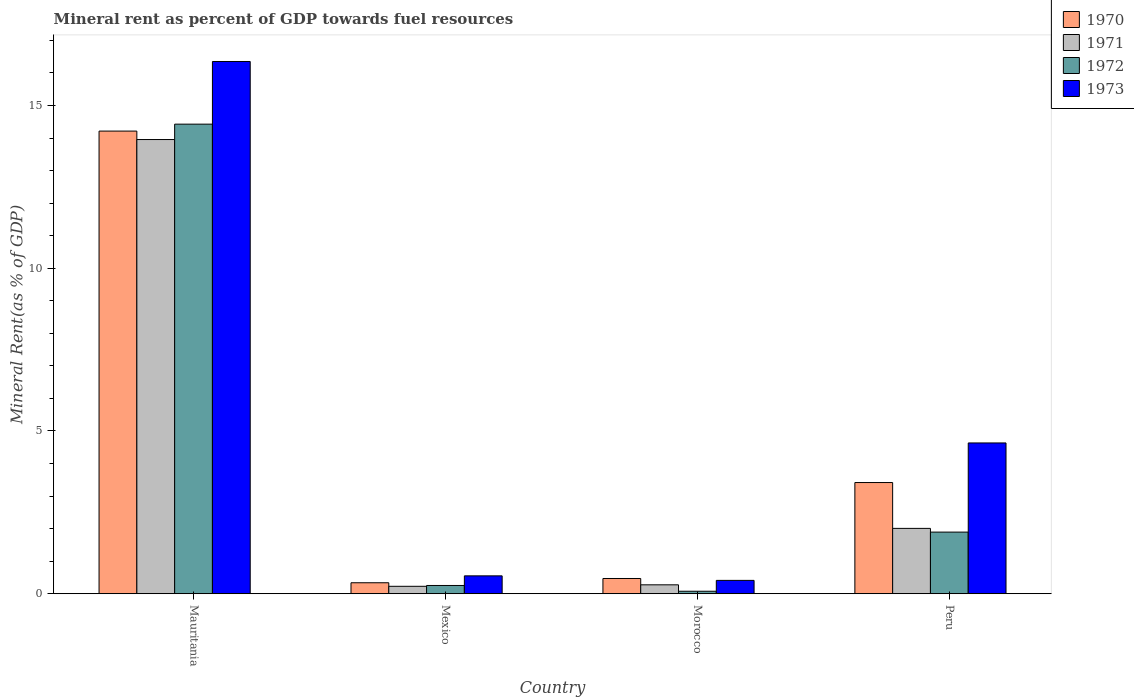How many groups of bars are there?
Ensure brevity in your answer.  4. Are the number of bars per tick equal to the number of legend labels?
Provide a succinct answer. Yes. How many bars are there on the 1st tick from the right?
Provide a succinct answer. 4. What is the label of the 3rd group of bars from the left?
Provide a short and direct response. Morocco. In how many cases, is the number of bars for a given country not equal to the number of legend labels?
Your answer should be compact. 0. What is the mineral rent in 1971 in Mexico?
Ensure brevity in your answer.  0.23. Across all countries, what is the maximum mineral rent in 1971?
Make the answer very short. 13.95. Across all countries, what is the minimum mineral rent in 1970?
Make the answer very short. 0.34. In which country was the mineral rent in 1970 maximum?
Make the answer very short. Mauritania. In which country was the mineral rent in 1972 minimum?
Provide a succinct answer. Morocco. What is the total mineral rent in 1970 in the graph?
Make the answer very short. 18.44. What is the difference between the mineral rent in 1971 in Morocco and that in Peru?
Provide a succinct answer. -1.73. What is the difference between the mineral rent in 1970 in Morocco and the mineral rent in 1971 in Mexico?
Provide a succinct answer. 0.24. What is the average mineral rent in 1972 per country?
Keep it short and to the point. 4.16. What is the difference between the mineral rent of/in 1971 and mineral rent of/in 1973 in Mexico?
Offer a very short reply. -0.32. What is the ratio of the mineral rent in 1970 in Morocco to that in Peru?
Your answer should be very brief. 0.14. Is the mineral rent in 1971 in Mauritania less than that in Mexico?
Provide a short and direct response. No. What is the difference between the highest and the second highest mineral rent in 1972?
Keep it short and to the point. -1.64. What is the difference between the highest and the lowest mineral rent in 1972?
Keep it short and to the point. 14.35. What does the 3rd bar from the left in Mauritania represents?
Ensure brevity in your answer.  1972. How many bars are there?
Provide a succinct answer. 16. Are the values on the major ticks of Y-axis written in scientific E-notation?
Your answer should be compact. No. Where does the legend appear in the graph?
Your answer should be very brief. Top right. How are the legend labels stacked?
Make the answer very short. Vertical. What is the title of the graph?
Offer a very short reply. Mineral rent as percent of GDP towards fuel resources. What is the label or title of the X-axis?
Give a very brief answer. Country. What is the label or title of the Y-axis?
Your answer should be compact. Mineral Rent(as % of GDP). What is the Mineral Rent(as % of GDP) of 1970 in Mauritania?
Ensure brevity in your answer.  14.21. What is the Mineral Rent(as % of GDP) in 1971 in Mauritania?
Provide a short and direct response. 13.95. What is the Mineral Rent(as % of GDP) of 1972 in Mauritania?
Give a very brief answer. 14.43. What is the Mineral Rent(as % of GDP) in 1973 in Mauritania?
Your answer should be very brief. 16.35. What is the Mineral Rent(as % of GDP) in 1970 in Mexico?
Provide a succinct answer. 0.34. What is the Mineral Rent(as % of GDP) of 1971 in Mexico?
Give a very brief answer. 0.23. What is the Mineral Rent(as % of GDP) in 1972 in Mexico?
Your response must be concise. 0.25. What is the Mineral Rent(as % of GDP) in 1973 in Mexico?
Your response must be concise. 0.55. What is the Mineral Rent(as % of GDP) of 1970 in Morocco?
Keep it short and to the point. 0.47. What is the Mineral Rent(as % of GDP) in 1971 in Morocco?
Provide a short and direct response. 0.27. What is the Mineral Rent(as % of GDP) in 1972 in Morocco?
Keep it short and to the point. 0.08. What is the Mineral Rent(as % of GDP) of 1973 in Morocco?
Keep it short and to the point. 0.41. What is the Mineral Rent(as % of GDP) of 1970 in Peru?
Your answer should be very brief. 3.42. What is the Mineral Rent(as % of GDP) in 1971 in Peru?
Make the answer very short. 2.01. What is the Mineral Rent(as % of GDP) of 1972 in Peru?
Ensure brevity in your answer.  1.89. What is the Mineral Rent(as % of GDP) in 1973 in Peru?
Make the answer very short. 4.63. Across all countries, what is the maximum Mineral Rent(as % of GDP) in 1970?
Provide a short and direct response. 14.21. Across all countries, what is the maximum Mineral Rent(as % of GDP) of 1971?
Offer a very short reply. 13.95. Across all countries, what is the maximum Mineral Rent(as % of GDP) of 1972?
Make the answer very short. 14.43. Across all countries, what is the maximum Mineral Rent(as % of GDP) of 1973?
Keep it short and to the point. 16.35. Across all countries, what is the minimum Mineral Rent(as % of GDP) of 1970?
Offer a terse response. 0.34. Across all countries, what is the minimum Mineral Rent(as % of GDP) in 1971?
Give a very brief answer. 0.23. Across all countries, what is the minimum Mineral Rent(as % of GDP) of 1972?
Make the answer very short. 0.08. Across all countries, what is the minimum Mineral Rent(as % of GDP) in 1973?
Ensure brevity in your answer.  0.41. What is the total Mineral Rent(as % of GDP) of 1970 in the graph?
Offer a very short reply. 18.44. What is the total Mineral Rent(as % of GDP) in 1971 in the graph?
Make the answer very short. 16.46. What is the total Mineral Rent(as % of GDP) in 1972 in the graph?
Your answer should be very brief. 16.65. What is the total Mineral Rent(as % of GDP) in 1973 in the graph?
Provide a succinct answer. 21.94. What is the difference between the Mineral Rent(as % of GDP) in 1970 in Mauritania and that in Mexico?
Give a very brief answer. 13.88. What is the difference between the Mineral Rent(as % of GDP) of 1971 in Mauritania and that in Mexico?
Make the answer very short. 13.72. What is the difference between the Mineral Rent(as % of GDP) in 1972 in Mauritania and that in Mexico?
Make the answer very short. 14.17. What is the difference between the Mineral Rent(as % of GDP) of 1973 in Mauritania and that in Mexico?
Provide a succinct answer. 15.8. What is the difference between the Mineral Rent(as % of GDP) in 1970 in Mauritania and that in Morocco?
Provide a short and direct response. 13.74. What is the difference between the Mineral Rent(as % of GDP) of 1971 in Mauritania and that in Morocco?
Ensure brevity in your answer.  13.68. What is the difference between the Mineral Rent(as % of GDP) of 1972 in Mauritania and that in Morocco?
Provide a short and direct response. 14.35. What is the difference between the Mineral Rent(as % of GDP) in 1973 in Mauritania and that in Morocco?
Give a very brief answer. 15.94. What is the difference between the Mineral Rent(as % of GDP) of 1970 in Mauritania and that in Peru?
Your answer should be very brief. 10.8. What is the difference between the Mineral Rent(as % of GDP) in 1971 in Mauritania and that in Peru?
Offer a terse response. 11.94. What is the difference between the Mineral Rent(as % of GDP) in 1972 in Mauritania and that in Peru?
Keep it short and to the point. 12.53. What is the difference between the Mineral Rent(as % of GDP) of 1973 in Mauritania and that in Peru?
Offer a very short reply. 11.72. What is the difference between the Mineral Rent(as % of GDP) of 1970 in Mexico and that in Morocco?
Ensure brevity in your answer.  -0.13. What is the difference between the Mineral Rent(as % of GDP) in 1971 in Mexico and that in Morocco?
Keep it short and to the point. -0.05. What is the difference between the Mineral Rent(as % of GDP) of 1972 in Mexico and that in Morocco?
Keep it short and to the point. 0.18. What is the difference between the Mineral Rent(as % of GDP) of 1973 in Mexico and that in Morocco?
Ensure brevity in your answer.  0.14. What is the difference between the Mineral Rent(as % of GDP) in 1970 in Mexico and that in Peru?
Offer a terse response. -3.08. What is the difference between the Mineral Rent(as % of GDP) in 1971 in Mexico and that in Peru?
Offer a terse response. -1.78. What is the difference between the Mineral Rent(as % of GDP) of 1972 in Mexico and that in Peru?
Offer a terse response. -1.64. What is the difference between the Mineral Rent(as % of GDP) of 1973 in Mexico and that in Peru?
Offer a terse response. -4.08. What is the difference between the Mineral Rent(as % of GDP) in 1970 in Morocco and that in Peru?
Keep it short and to the point. -2.95. What is the difference between the Mineral Rent(as % of GDP) of 1971 in Morocco and that in Peru?
Provide a succinct answer. -1.73. What is the difference between the Mineral Rent(as % of GDP) of 1972 in Morocco and that in Peru?
Provide a short and direct response. -1.82. What is the difference between the Mineral Rent(as % of GDP) of 1973 in Morocco and that in Peru?
Provide a succinct answer. -4.22. What is the difference between the Mineral Rent(as % of GDP) in 1970 in Mauritania and the Mineral Rent(as % of GDP) in 1971 in Mexico?
Your response must be concise. 13.98. What is the difference between the Mineral Rent(as % of GDP) of 1970 in Mauritania and the Mineral Rent(as % of GDP) of 1972 in Mexico?
Your response must be concise. 13.96. What is the difference between the Mineral Rent(as % of GDP) in 1970 in Mauritania and the Mineral Rent(as % of GDP) in 1973 in Mexico?
Your answer should be very brief. 13.66. What is the difference between the Mineral Rent(as % of GDP) of 1971 in Mauritania and the Mineral Rent(as % of GDP) of 1972 in Mexico?
Your answer should be compact. 13.7. What is the difference between the Mineral Rent(as % of GDP) in 1971 in Mauritania and the Mineral Rent(as % of GDP) in 1973 in Mexico?
Give a very brief answer. 13.4. What is the difference between the Mineral Rent(as % of GDP) of 1972 in Mauritania and the Mineral Rent(as % of GDP) of 1973 in Mexico?
Provide a short and direct response. 13.88. What is the difference between the Mineral Rent(as % of GDP) in 1970 in Mauritania and the Mineral Rent(as % of GDP) in 1971 in Morocco?
Make the answer very short. 13.94. What is the difference between the Mineral Rent(as % of GDP) of 1970 in Mauritania and the Mineral Rent(as % of GDP) of 1972 in Morocco?
Give a very brief answer. 14.14. What is the difference between the Mineral Rent(as % of GDP) of 1970 in Mauritania and the Mineral Rent(as % of GDP) of 1973 in Morocco?
Provide a succinct answer. 13.8. What is the difference between the Mineral Rent(as % of GDP) in 1971 in Mauritania and the Mineral Rent(as % of GDP) in 1972 in Morocco?
Provide a short and direct response. 13.88. What is the difference between the Mineral Rent(as % of GDP) in 1971 in Mauritania and the Mineral Rent(as % of GDP) in 1973 in Morocco?
Give a very brief answer. 13.54. What is the difference between the Mineral Rent(as % of GDP) of 1972 in Mauritania and the Mineral Rent(as % of GDP) of 1973 in Morocco?
Ensure brevity in your answer.  14.02. What is the difference between the Mineral Rent(as % of GDP) in 1970 in Mauritania and the Mineral Rent(as % of GDP) in 1971 in Peru?
Your answer should be very brief. 12.2. What is the difference between the Mineral Rent(as % of GDP) of 1970 in Mauritania and the Mineral Rent(as % of GDP) of 1972 in Peru?
Provide a succinct answer. 12.32. What is the difference between the Mineral Rent(as % of GDP) of 1970 in Mauritania and the Mineral Rent(as % of GDP) of 1973 in Peru?
Offer a terse response. 9.58. What is the difference between the Mineral Rent(as % of GDP) of 1971 in Mauritania and the Mineral Rent(as % of GDP) of 1972 in Peru?
Offer a terse response. 12.06. What is the difference between the Mineral Rent(as % of GDP) in 1971 in Mauritania and the Mineral Rent(as % of GDP) in 1973 in Peru?
Ensure brevity in your answer.  9.32. What is the difference between the Mineral Rent(as % of GDP) in 1972 in Mauritania and the Mineral Rent(as % of GDP) in 1973 in Peru?
Ensure brevity in your answer.  9.79. What is the difference between the Mineral Rent(as % of GDP) in 1970 in Mexico and the Mineral Rent(as % of GDP) in 1971 in Morocco?
Your answer should be compact. 0.06. What is the difference between the Mineral Rent(as % of GDP) of 1970 in Mexico and the Mineral Rent(as % of GDP) of 1972 in Morocco?
Offer a terse response. 0.26. What is the difference between the Mineral Rent(as % of GDP) of 1970 in Mexico and the Mineral Rent(as % of GDP) of 1973 in Morocco?
Your response must be concise. -0.07. What is the difference between the Mineral Rent(as % of GDP) in 1971 in Mexico and the Mineral Rent(as % of GDP) in 1972 in Morocco?
Give a very brief answer. 0.15. What is the difference between the Mineral Rent(as % of GDP) of 1971 in Mexico and the Mineral Rent(as % of GDP) of 1973 in Morocco?
Offer a terse response. -0.18. What is the difference between the Mineral Rent(as % of GDP) in 1972 in Mexico and the Mineral Rent(as % of GDP) in 1973 in Morocco?
Provide a succinct answer. -0.16. What is the difference between the Mineral Rent(as % of GDP) of 1970 in Mexico and the Mineral Rent(as % of GDP) of 1971 in Peru?
Your response must be concise. -1.67. What is the difference between the Mineral Rent(as % of GDP) in 1970 in Mexico and the Mineral Rent(as % of GDP) in 1972 in Peru?
Make the answer very short. -1.56. What is the difference between the Mineral Rent(as % of GDP) in 1970 in Mexico and the Mineral Rent(as % of GDP) in 1973 in Peru?
Make the answer very short. -4.29. What is the difference between the Mineral Rent(as % of GDP) in 1971 in Mexico and the Mineral Rent(as % of GDP) in 1972 in Peru?
Give a very brief answer. -1.67. What is the difference between the Mineral Rent(as % of GDP) in 1971 in Mexico and the Mineral Rent(as % of GDP) in 1973 in Peru?
Your answer should be compact. -4.4. What is the difference between the Mineral Rent(as % of GDP) in 1972 in Mexico and the Mineral Rent(as % of GDP) in 1973 in Peru?
Provide a succinct answer. -4.38. What is the difference between the Mineral Rent(as % of GDP) of 1970 in Morocco and the Mineral Rent(as % of GDP) of 1971 in Peru?
Your answer should be very brief. -1.54. What is the difference between the Mineral Rent(as % of GDP) of 1970 in Morocco and the Mineral Rent(as % of GDP) of 1972 in Peru?
Your answer should be compact. -1.43. What is the difference between the Mineral Rent(as % of GDP) of 1970 in Morocco and the Mineral Rent(as % of GDP) of 1973 in Peru?
Provide a succinct answer. -4.16. What is the difference between the Mineral Rent(as % of GDP) in 1971 in Morocco and the Mineral Rent(as % of GDP) in 1972 in Peru?
Give a very brief answer. -1.62. What is the difference between the Mineral Rent(as % of GDP) of 1971 in Morocco and the Mineral Rent(as % of GDP) of 1973 in Peru?
Provide a succinct answer. -4.36. What is the difference between the Mineral Rent(as % of GDP) in 1972 in Morocco and the Mineral Rent(as % of GDP) in 1973 in Peru?
Give a very brief answer. -4.56. What is the average Mineral Rent(as % of GDP) in 1970 per country?
Your response must be concise. 4.61. What is the average Mineral Rent(as % of GDP) of 1971 per country?
Your answer should be compact. 4.12. What is the average Mineral Rent(as % of GDP) of 1972 per country?
Offer a terse response. 4.16. What is the average Mineral Rent(as % of GDP) of 1973 per country?
Give a very brief answer. 5.49. What is the difference between the Mineral Rent(as % of GDP) of 1970 and Mineral Rent(as % of GDP) of 1971 in Mauritania?
Make the answer very short. 0.26. What is the difference between the Mineral Rent(as % of GDP) in 1970 and Mineral Rent(as % of GDP) in 1972 in Mauritania?
Offer a very short reply. -0.21. What is the difference between the Mineral Rent(as % of GDP) of 1970 and Mineral Rent(as % of GDP) of 1973 in Mauritania?
Your response must be concise. -2.14. What is the difference between the Mineral Rent(as % of GDP) in 1971 and Mineral Rent(as % of GDP) in 1972 in Mauritania?
Provide a succinct answer. -0.47. What is the difference between the Mineral Rent(as % of GDP) in 1971 and Mineral Rent(as % of GDP) in 1973 in Mauritania?
Provide a short and direct response. -2.4. What is the difference between the Mineral Rent(as % of GDP) in 1972 and Mineral Rent(as % of GDP) in 1973 in Mauritania?
Provide a short and direct response. -1.93. What is the difference between the Mineral Rent(as % of GDP) in 1970 and Mineral Rent(as % of GDP) in 1971 in Mexico?
Keep it short and to the point. 0.11. What is the difference between the Mineral Rent(as % of GDP) of 1970 and Mineral Rent(as % of GDP) of 1972 in Mexico?
Keep it short and to the point. 0.08. What is the difference between the Mineral Rent(as % of GDP) in 1970 and Mineral Rent(as % of GDP) in 1973 in Mexico?
Your answer should be compact. -0.21. What is the difference between the Mineral Rent(as % of GDP) of 1971 and Mineral Rent(as % of GDP) of 1972 in Mexico?
Make the answer very short. -0.03. What is the difference between the Mineral Rent(as % of GDP) in 1971 and Mineral Rent(as % of GDP) in 1973 in Mexico?
Your response must be concise. -0.32. What is the difference between the Mineral Rent(as % of GDP) of 1972 and Mineral Rent(as % of GDP) of 1973 in Mexico?
Keep it short and to the point. -0.3. What is the difference between the Mineral Rent(as % of GDP) of 1970 and Mineral Rent(as % of GDP) of 1971 in Morocco?
Provide a short and direct response. 0.19. What is the difference between the Mineral Rent(as % of GDP) in 1970 and Mineral Rent(as % of GDP) in 1972 in Morocco?
Your answer should be compact. 0.39. What is the difference between the Mineral Rent(as % of GDP) of 1970 and Mineral Rent(as % of GDP) of 1973 in Morocco?
Give a very brief answer. 0.06. What is the difference between the Mineral Rent(as % of GDP) in 1971 and Mineral Rent(as % of GDP) in 1972 in Morocco?
Provide a succinct answer. 0.2. What is the difference between the Mineral Rent(as % of GDP) of 1971 and Mineral Rent(as % of GDP) of 1973 in Morocco?
Your answer should be compact. -0.14. What is the difference between the Mineral Rent(as % of GDP) in 1972 and Mineral Rent(as % of GDP) in 1973 in Morocco?
Keep it short and to the point. -0.33. What is the difference between the Mineral Rent(as % of GDP) in 1970 and Mineral Rent(as % of GDP) in 1971 in Peru?
Give a very brief answer. 1.41. What is the difference between the Mineral Rent(as % of GDP) in 1970 and Mineral Rent(as % of GDP) in 1972 in Peru?
Provide a succinct answer. 1.52. What is the difference between the Mineral Rent(as % of GDP) of 1970 and Mineral Rent(as % of GDP) of 1973 in Peru?
Provide a succinct answer. -1.22. What is the difference between the Mineral Rent(as % of GDP) of 1971 and Mineral Rent(as % of GDP) of 1972 in Peru?
Keep it short and to the point. 0.11. What is the difference between the Mineral Rent(as % of GDP) in 1971 and Mineral Rent(as % of GDP) in 1973 in Peru?
Provide a succinct answer. -2.62. What is the difference between the Mineral Rent(as % of GDP) in 1972 and Mineral Rent(as % of GDP) in 1973 in Peru?
Ensure brevity in your answer.  -2.74. What is the ratio of the Mineral Rent(as % of GDP) in 1970 in Mauritania to that in Mexico?
Provide a succinct answer. 42.1. What is the ratio of the Mineral Rent(as % of GDP) in 1971 in Mauritania to that in Mexico?
Ensure brevity in your answer.  61.1. What is the ratio of the Mineral Rent(as % of GDP) of 1972 in Mauritania to that in Mexico?
Your response must be concise. 56.78. What is the ratio of the Mineral Rent(as % of GDP) in 1973 in Mauritania to that in Mexico?
Ensure brevity in your answer.  29.75. What is the ratio of the Mineral Rent(as % of GDP) of 1970 in Mauritania to that in Morocco?
Your answer should be very brief. 30.32. What is the ratio of the Mineral Rent(as % of GDP) of 1971 in Mauritania to that in Morocco?
Make the answer very short. 50.9. What is the ratio of the Mineral Rent(as % of GDP) of 1972 in Mauritania to that in Morocco?
Provide a succinct answer. 187.82. What is the ratio of the Mineral Rent(as % of GDP) of 1973 in Mauritania to that in Morocco?
Provide a short and direct response. 39.85. What is the ratio of the Mineral Rent(as % of GDP) of 1970 in Mauritania to that in Peru?
Offer a terse response. 4.16. What is the ratio of the Mineral Rent(as % of GDP) in 1971 in Mauritania to that in Peru?
Your answer should be compact. 6.95. What is the ratio of the Mineral Rent(as % of GDP) of 1972 in Mauritania to that in Peru?
Keep it short and to the point. 7.62. What is the ratio of the Mineral Rent(as % of GDP) of 1973 in Mauritania to that in Peru?
Offer a terse response. 3.53. What is the ratio of the Mineral Rent(as % of GDP) in 1970 in Mexico to that in Morocco?
Make the answer very short. 0.72. What is the ratio of the Mineral Rent(as % of GDP) of 1971 in Mexico to that in Morocco?
Your answer should be very brief. 0.83. What is the ratio of the Mineral Rent(as % of GDP) of 1972 in Mexico to that in Morocco?
Keep it short and to the point. 3.31. What is the ratio of the Mineral Rent(as % of GDP) of 1973 in Mexico to that in Morocco?
Offer a very short reply. 1.34. What is the ratio of the Mineral Rent(as % of GDP) in 1970 in Mexico to that in Peru?
Your answer should be very brief. 0.1. What is the ratio of the Mineral Rent(as % of GDP) in 1971 in Mexico to that in Peru?
Your answer should be very brief. 0.11. What is the ratio of the Mineral Rent(as % of GDP) in 1972 in Mexico to that in Peru?
Offer a very short reply. 0.13. What is the ratio of the Mineral Rent(as % of GDP) of 1973 in Mexico to that in Peru?
Your answer should be very brief. 0.12. What is the ratio of the Mineral Rent(as % of GDP) of 1970 in Morocco to that in Peru?
Give a very brief answer. 0.14. What is the ratio of the Mineral Rent(as % of GDP) in 1971 in Morocco to that in Peru?
Your answer should be compact. 0.14. What is the ratio of the Mineral Rent(as % of GDP) in 1972 in Morocco to that in Peru?
Your response must be concise. 0.04. What is the ratio of the Mineral Rent(as % of GDP) of 1973 in Morocco to that in Peru?
Your answer should be very brief. 0.09. What is the difference between the highest and the second highest Mineral Rent(as % of GDP) in 1970?
Your answer should be very brief. 10.8. What is the difference between the highest and the second highest Mineral Rent(as % of GDP) of 1971?
Your answer should be very brief. 11.94. What is the difference between the highest and the second highest Mineral Rent(as % of GDP) of 1972?
Your response must be concise. 12.53. What is the difference between the highest and the second highest Mineral Rent(as % of GDP) of 1973?
Provide a succinct answer. 11.72. What is the difference between the highest and the lowest Mineral Rent(as % of GDP) of 1970?
Your answer should be compact. 13.88. What is the difference between the highest and the lowest Mineral Rent(as % of GDP) of 1971?
Keep it short and to the point. 13.72. What is the difference between the highest and the lowest Mineral Rent(as % of GDP) of 1972?
Ensure brevity in your answer.  14.35. What is the difference between the highest and the lowest Mineral Rent(as % of GDP) of 1973?
Keep it short and to the point. 15.94. 